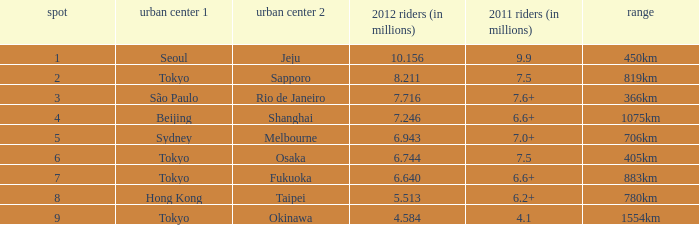What the is the first city listed on the route that had 6.6+ passengers in 2011 and a distance of 1075km? Beijing. 